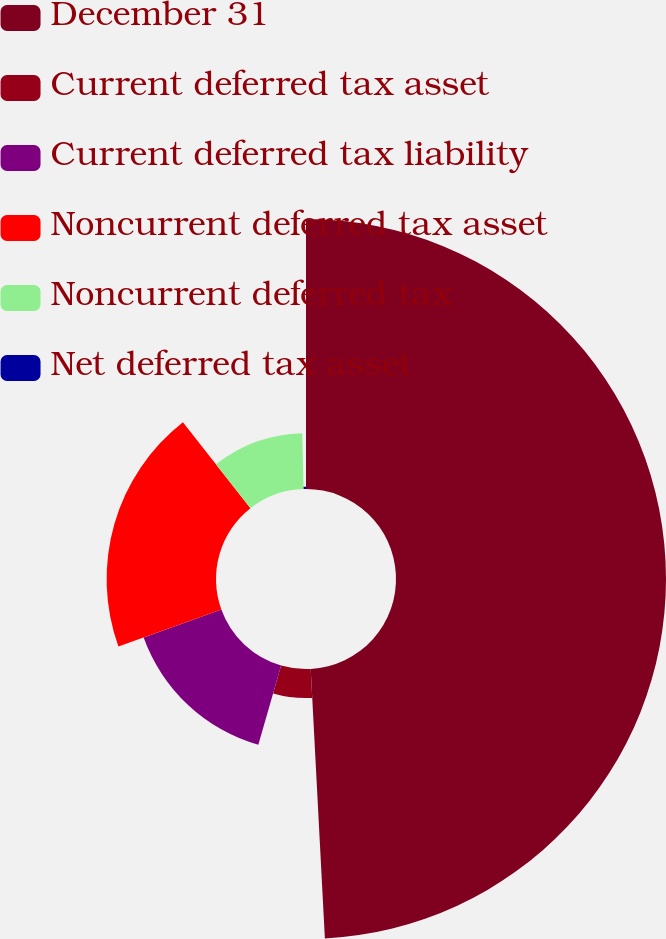<chart> <loc_0><loc_0><loc_500><loc_500><pie_chart><fcel>December 31<fcel>Current deferred tax asset<fcel>Current deferred tax liability<fcel>Noncurrent deferred tax asset<fcel>Noncurrent deferred tax<fcel>Net deferred tax asset<nl><fcel>49.17%<fcel>5.29%<fcel>15.04%<fcel>19.92%<fcel>10.17%<fcel>0.42%<nl></chart> 